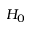Convert formula to latex. <formula><loc_0><loc_0><loc_500><loc_500>H _ { 0 }</formula> 